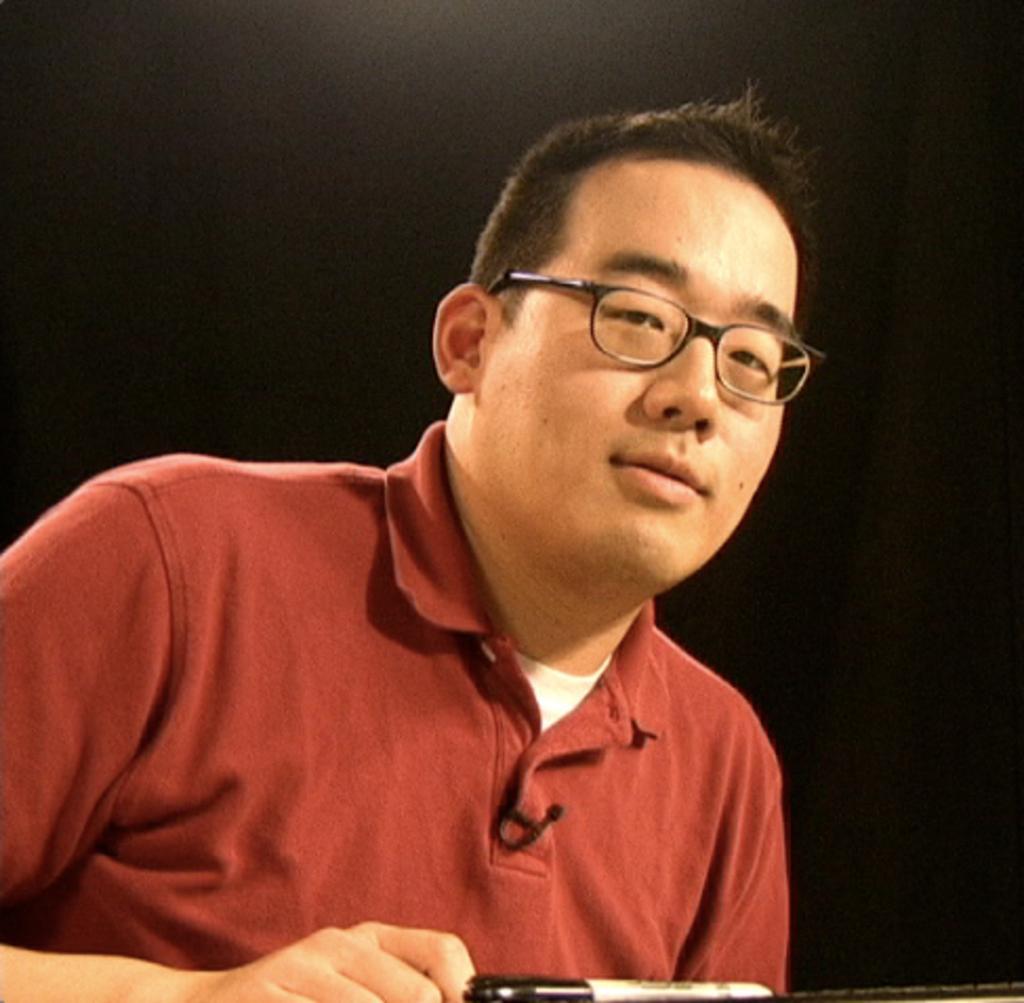How would you summarize this image in a sentence or two? In this image I see man, who is wearing a t-shirt and he is wearing a spectacle. 